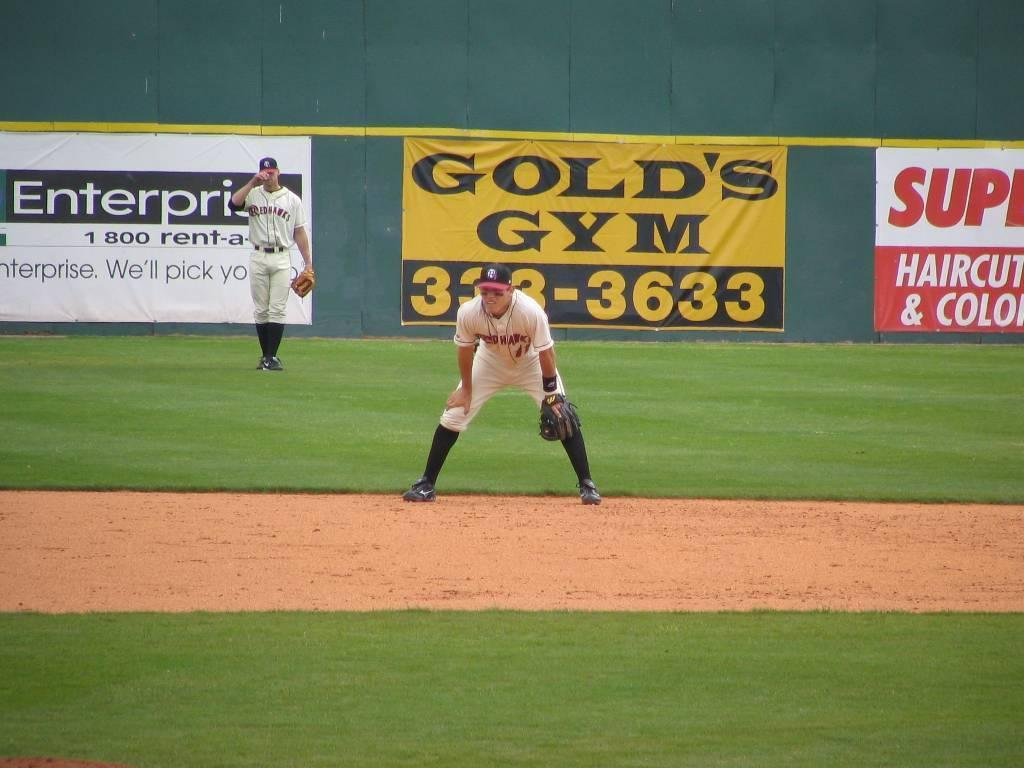<image>
Render a clear and concise summary of the photo. One of the sponsor's for the baseball team is Gold's Gym. 